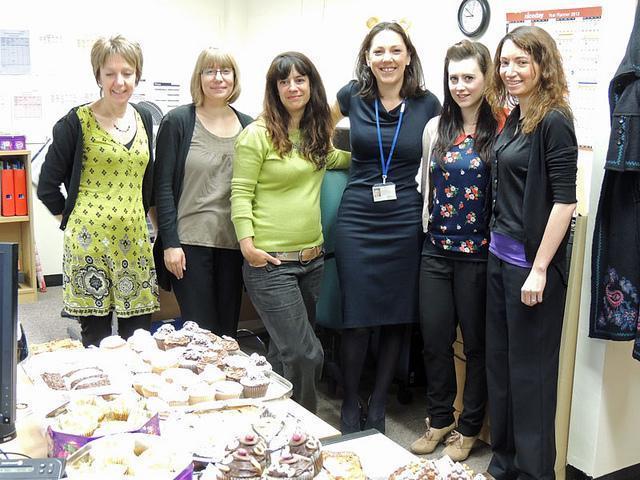How many people are in the photo?
Give a very brief answer. 6. How many women are standing?
Give a very brief answer. 6. How many people are visible?
Give a very brief answer. 6. 